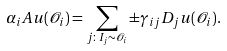Convert formula to latex. <formula><loc_0><loc_0><loc_500><loc_500>\alpha _ { i } A u ( \mathcal { O } _ { i } ) = \sum _ { j \colon I _ { j } \sim \mathcal { O } _ { i } } \pm \gamma _ { i j } D _ { j } u ( \mathcal { O } _ { i } ) .</formula> 